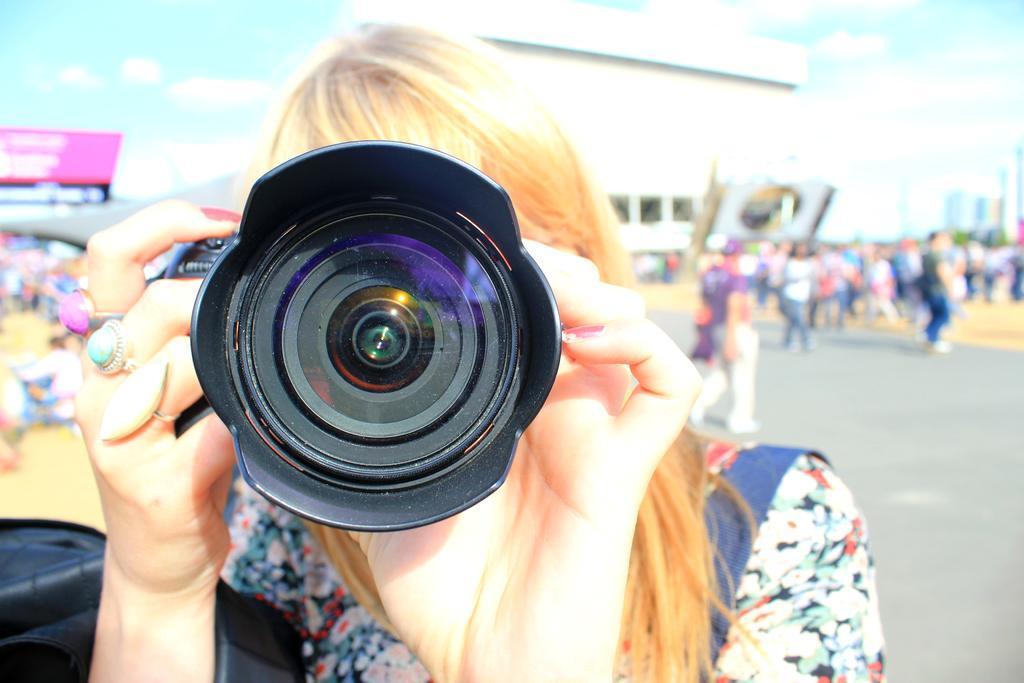Can you describe this image briefly? There is a group of people. She is holding a camera. She is wearing hand rings On the background we can see there is a building,tree,sky and road. Some persons are walking on a roads. 